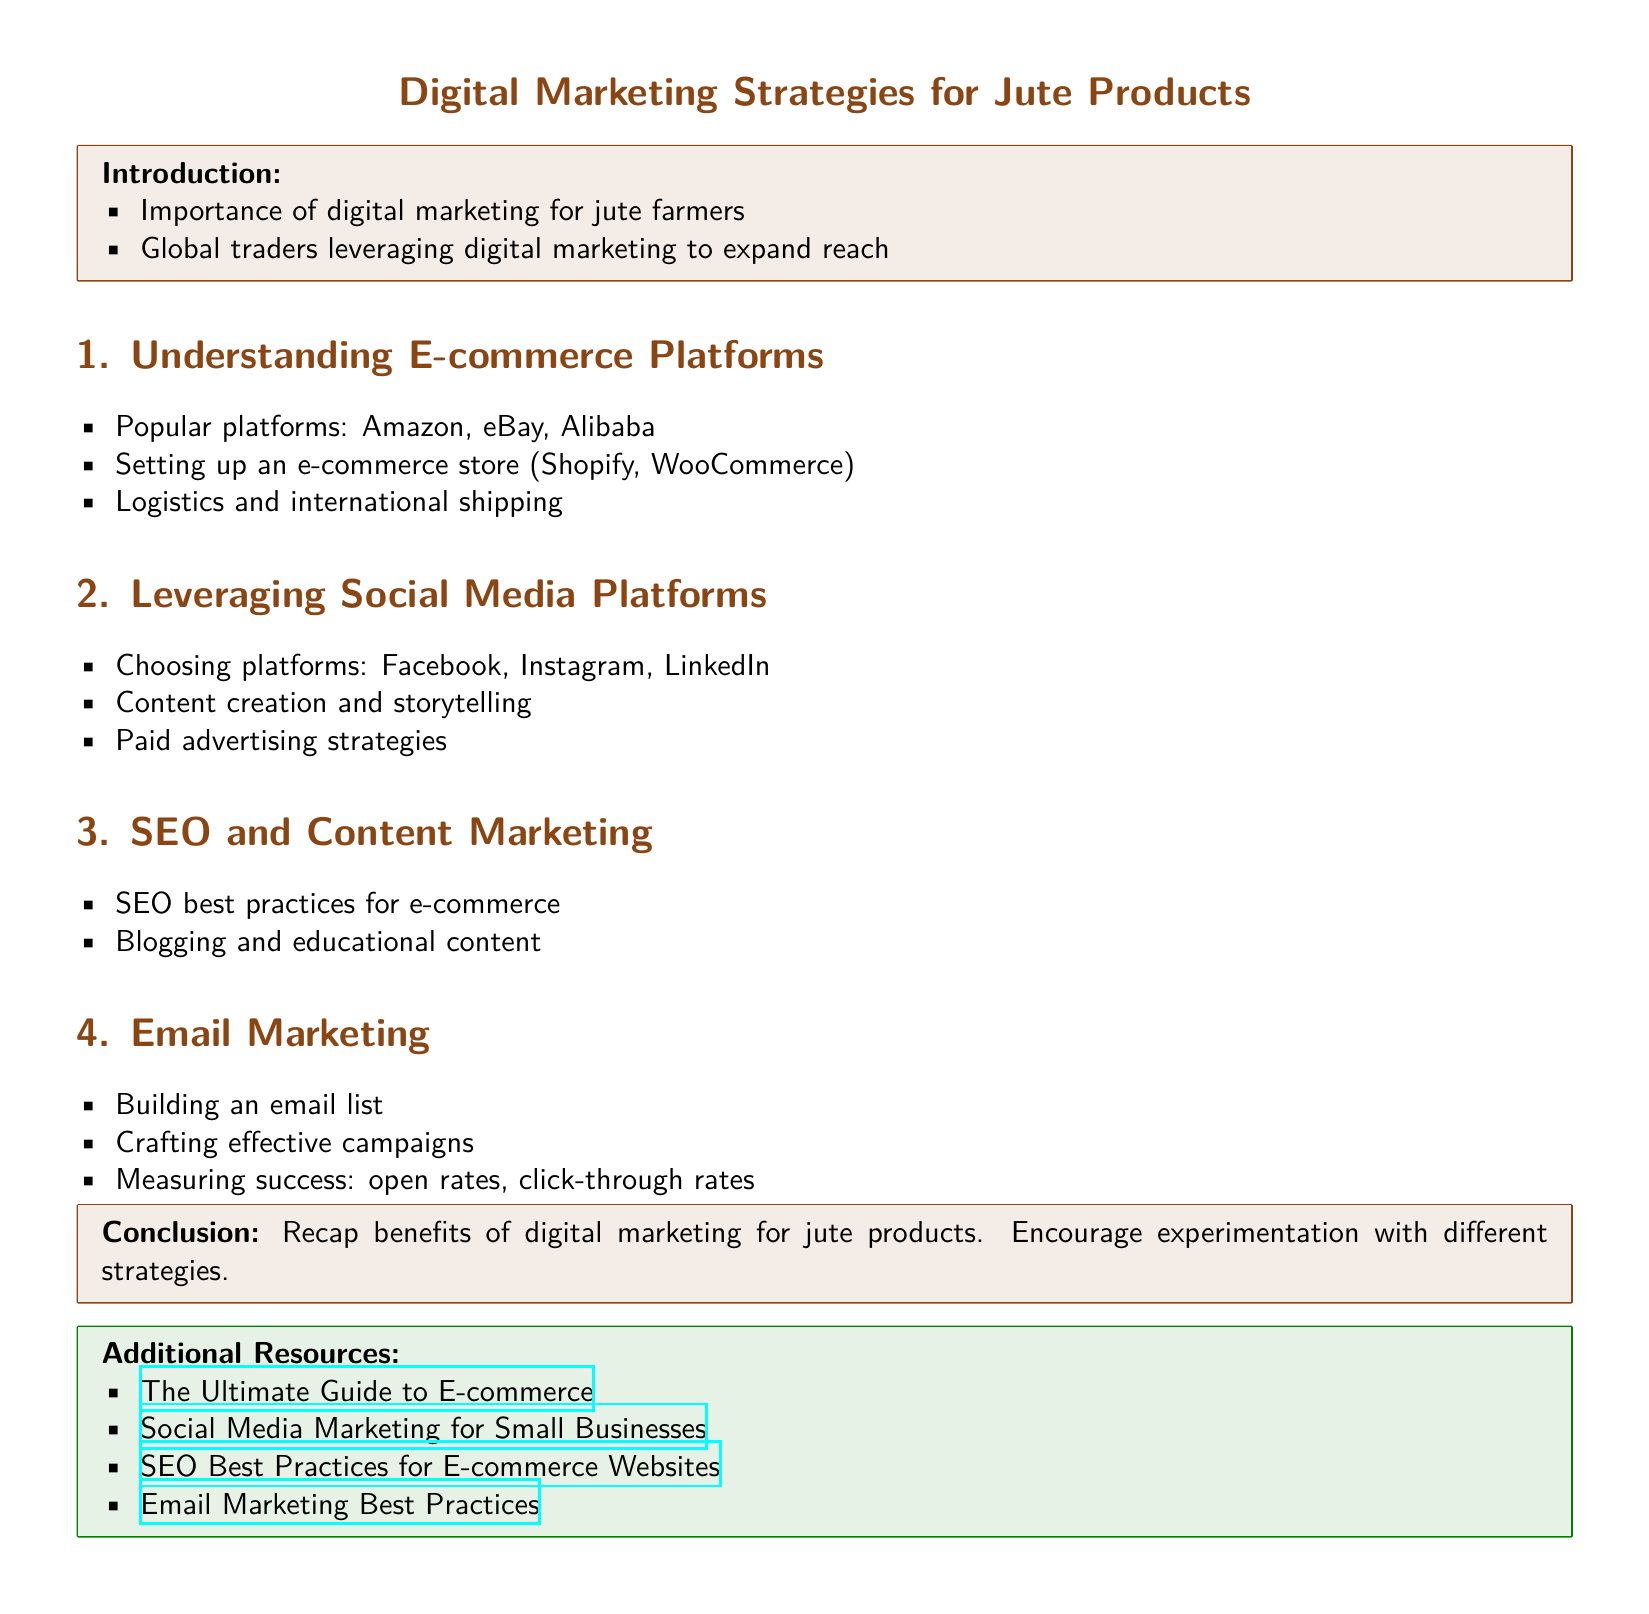What is the title of the lesson plan? The title is provided at the top of the document and introduces the main topic.
Answer: Digital Marketing Strategies for Jute Products What is one popular e-commerce platform mentioned? The document mentions several e-commerce platforms in the section discussing e-commerce, requiring retrieval of specific examples.
Answer: Amazon Which social media platform is suggested for paid advertising strategies? The document outlines specific platforms in the social media section, and this question seeks to identify one.
Answer: Facebook What is a key component of email marketing mentioned? The section on email marketing lists several important aspects, requiring identification of one.
Answer: Building an email list What is emphasized in the conclusion of the lesson plan? The conclusion summarizes the overall purpose and encourages specific actions related to digital marketing.
Answer: Benefits of digital marketing for jute products What type of content is suggested for content marketing? The SEO and Content Marketing section advises on types of content to create, which is addressed in this question.
Answer: Blogging and educational content How many main sections are there in the lesson plan? To answer, one would need to count the distinct section headings presented in the document.
Answer: Four Which color is used for section headings? The document's format specifies a color for section titles, prompting identification of that color.
Answer: Jute brown 